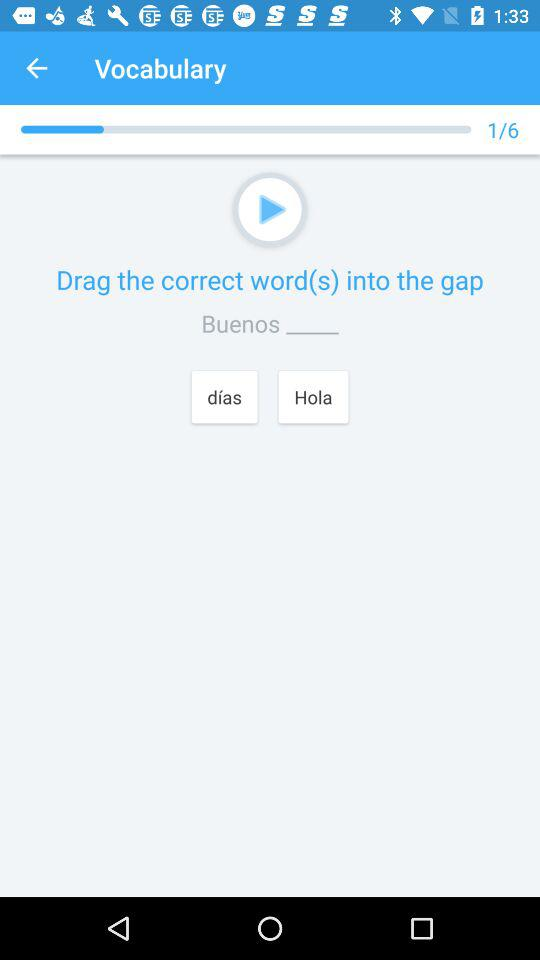How many vocabulary questions are there? There are six vocabulary questions. 